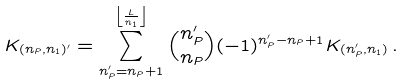<formula> <loc_0><loc_0><loc_500><loc_500>K _ { ( n _ { P } , n _ { 1 } ) ^ { \prime } } = \sum _ { n _ { P } ^ { \prime } = n _ { P } + 1 } ^ { \left \lfloor \frac { L } { n _ { 1 } } \right \rfloor } { n _ { P } ^ { \prime } \choose n _ { P } } ( - 1 ) ^ { n _ { P } ^ { \prime } - n _ { P } + 1 } K _ { ( n _ { P } ^ { \prime } , n _ { 1 } ) } \, .</formula> 